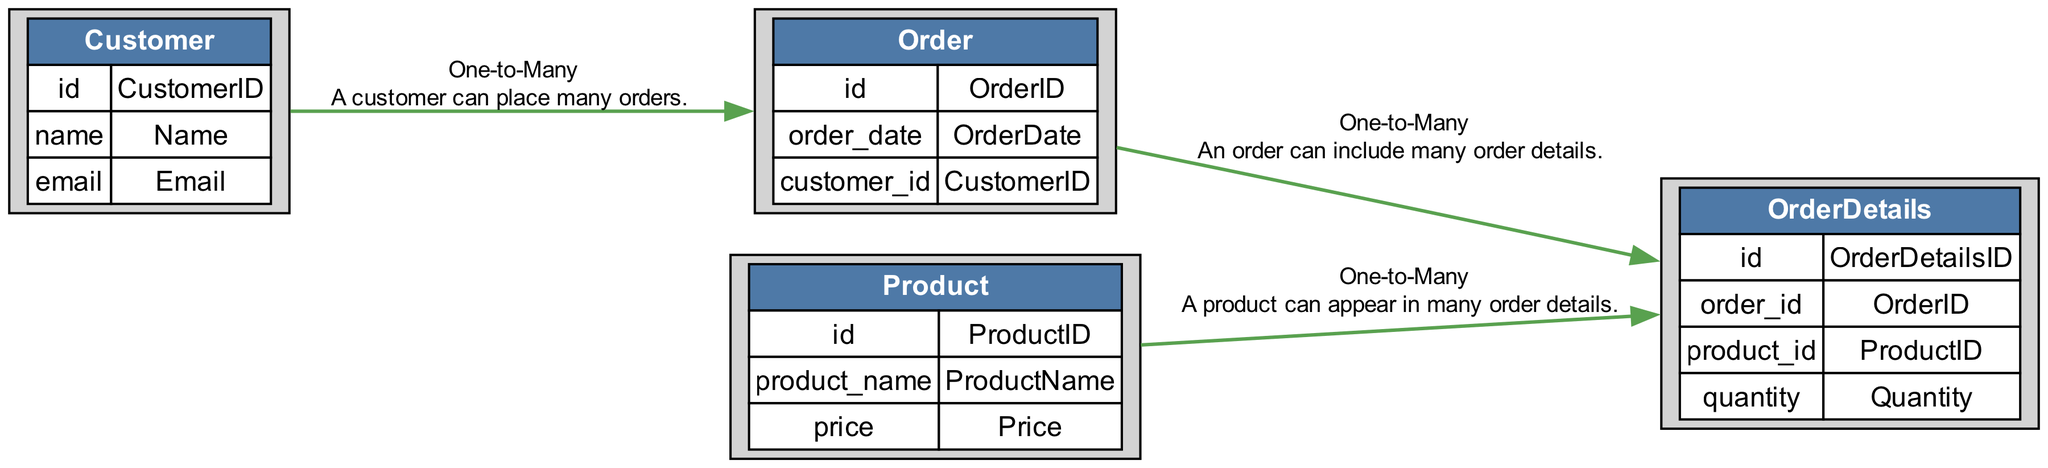What is the primary key of the Customer entity? The primary key for the Customer entity is identified in the diagram as CustomerID. It is marked clearly under the attributes section and is specified as a "Primary Key".
Answer: CustomerID How many entities are there in the diagram? To find the number of entities, we count the distinct tables represented in the diagram. There are four entities: Customer, Order, Product, and OrderDetails.
Answer: Four What type of relationship exists between Order and OrderDetails? The diagram outlines the relationship type as "One-to-Many". This means that one order can have multiple order details, which is explicitly mentioned in the edge description between these two entities.
Answer: One-to-Many Which entity serves as a foreign key in the Order entity? In the Order entity, the foreign key is identified as CustomerID. This attribute connects the Order entity to the Customer entity, allowing us to link orders to the corresponding customers.
Answer: CustomerID How many foreign keys are present in the OrderDetails entity? In the OrderDetails entity, there are two foreign keys: OrderID and ProductID. Each foreign key represents a relationship with its respective parent entity, allowing for proper connections in the relational structure.
Answer: Two What is the relationship between Customer and Order? The diagram specifies that the relationship is "One-to-Many". This indicates that a single customer can place multiple orders, linking the two entities in a hierarchical manner.
Answer: One-to-Many Which attribute represents price in the Product entity? The attribute that represents the price in the Product entity is identified as Price. It is clearly labeled and categorized as a "Decimal" data type under the attributes of the Product.
Answer: Price How many edges are drawn in the diagram? To determine the number of edges, we count the connections between the entities represented in the diagram. There are three edges drawn, each representing the relationships between the various entities.
Answer: Three Which table can a product appear in multiple times according to the diagram? According to the diagram, a product can appear multiple times in the OrderDetails table. This is denoted by the "One-to-Many" relationship from Product to OrderDetails.
Answer: OrderDetails 